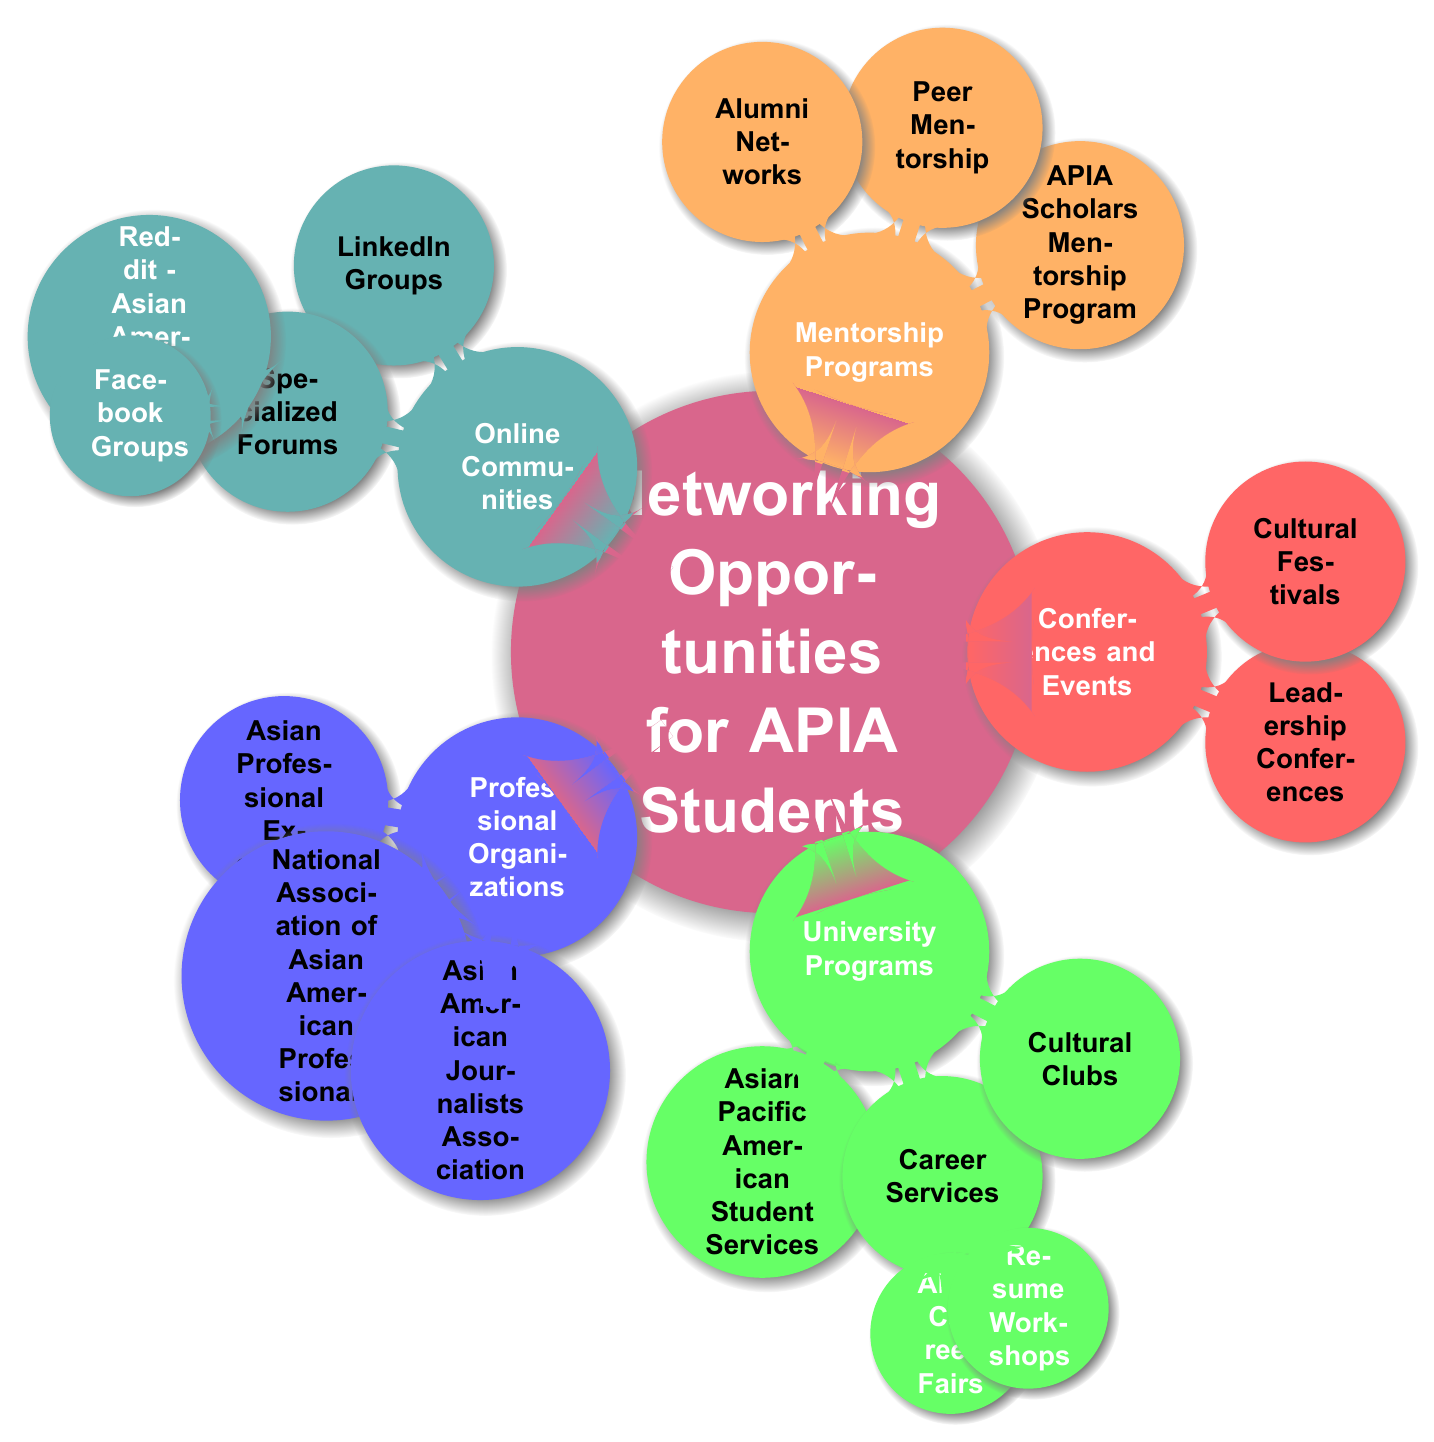What are the three main categories of networking opportunities for APIA students? The diagram identifies five main categories: Professional Organizations, University Programs, Conferences and Events, Mentorship Programs, and Online Communities.
Answer: Professional Organizations, University Programs, Conferences and Events, Mentorship Programs, Online Communities How many organizations fall under Professional Organizations? The Professional Organizations node branches into three specific organizations: Asian Professional Exchange, National Association of Asian American Professionals, and Asian American Journalists Association. Thus, the count is determined directly by the sub-nodes.
Answer: 3 Which node includes the APIA Career Fairs? To find the APIA Career Fairs, we trace from the top node "Networking Opportunities for APIA Students" to "University Programs", then to "Career Services", leading directly to "APIA Career Fairs". Therefore, the specific location of this node is clear through this path.
Answer: Career Services Which types of events are categorized under Conferences and Events? The Conferences and Events node contains two child nodes: Leadership Conferences and Cultural Festivals. Each of these represents different types of events, which can further be categorized based on their theme. Hence, both Leadership Conferences and Cultural Festivals are valid answers.
Answer: Leadership Conferences, Cultural Festivals What are two platforms mentioned under Specialized Forums? The diagram indicates that the Specialized Forums node branches into two specific groups: Reddit - Asian American Students and Facebook Groups. To arrive at these platforms, one can easily follow the diagram's nodes down to Specialized Forums.
Answer: Reddit - Asian American Students, Facebook Groups How many unique events or programs are listed under Cultural Festivals? From the Cultural Festivals node, there are two specific events mentioned: Lunar New Year Celebrations and Diwali Festivals. Each event can be counted directly from the diagram, giving us the total number.
Answer: 2 What type of networking program is the APIA Scholars Mentorship Program classified under? The APIA Scholars Mentorship Program is located directly under Mentorship Programs. To answer the question, one simply follows the node path downwards to identify its category.
Answer: Mentorship Programs How many LinkedIn groups are listed under Online Communities? Under the Online Communities node, the LinkedIn Groups have two listed groups: APIA Professionals Network and Young Asian Professionals Group. The count can be confirmed through observation of the sub-nodes related to this particular category.
Answer: 2 